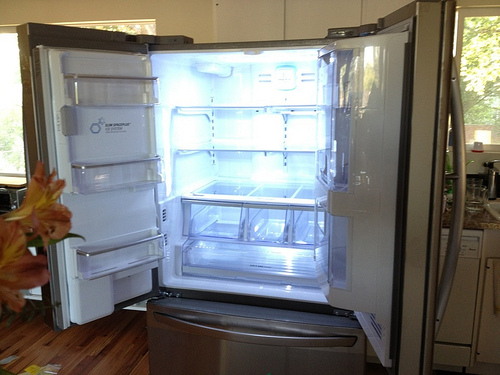Please provide a short description for this region: [0.01, 0.49, 0.13, 0.77]. Within these coordinates, a blurred segment of vibrant orange lilies can be observed, introducing a warm, lively tone at the edge of the frame. 